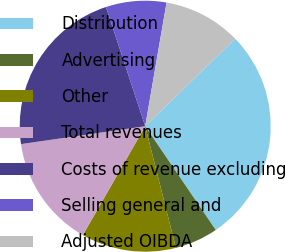Convert chart. <chart><loc_0><loc_0><loc_500><loc_500><pie_chart><fcel>Distribution<fcel>Advertising<fcel>Other<fcel>Total revenues<fcel>Costs of revenue excluding<fcel>Selling general and<fcel>Adjusted OIBDA<nl><fcel>27.78%<fcel>5.56%<fcel>12.22%<fcel>14.44%<fcel>22.22%<fcel>7.78%<fcel>10.0%<nl></chart> 